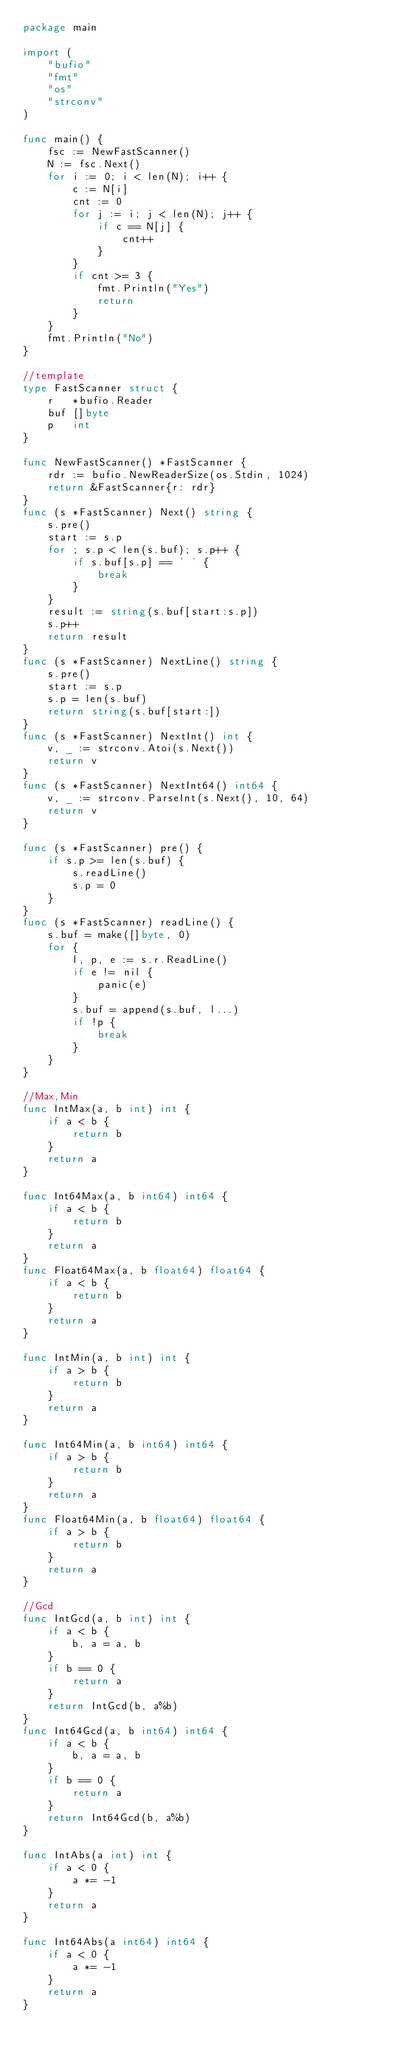Convert code to text. <code><loc_0><loc_0><loc_500><loc_500><_Go_>package main

import (
	"bufio"
	"fmt"
	"os"
	"strconv"
)

func main() {
	fsc := NewFastScanner()
	N := fsc.Next()
	for i := 0; i < len(N); i++ {
		c := N[i]
		cnt := 0
		for j := i; j < len(N); j++ {
			if c == N[j] {
				cnt++
			}
		}
		if cnt >= 3 {
			fmt.Println("Yes")
			return
		}
	}
	fmt.Println("No")
}

//template
type FastScanner struct {
	r   *bufio.Reader
	buf []byte
	p   int
}

func NewFastScanner() *FastScanner {
	rdr := bufio.NewReaderSize(os.Stdin, 1024)
	return &FastScanner{r: rdr}
}
func (s *FastScanner) Next() string {
	s.pre()
	start := s.p
	for ; s.p < len(s.buf); s.p++ {
		if s.buf[s.p] == ' ' {
			break
		}
	}
	result := string(s.buf[start:s.p])
	s.p++
	return result
}
func (s *FastScanner) NextLine() string {
	s.pre()
	start := s.p
	s.p = len(s.buf)
	return string(s.buf[start:])
}
func (s *FastScanner) NextInt() int {
	v, _ := strconv.Atoi(s.Next())
	return v
}
func (s *FastScanner) NextInt64() int64 {
	v, _ := strconv.ParseInt(s.Next(), 10, 64)
	return v
}

func (s *FastScanner) pre() {
	if s.p >= len(s.buf) {
		s.readLine()
		s.p = 0
	}
}
func (s *FastScanner) readLine() {
	s.buf = make([]byte, 0)
	for {
		l, p, e := s.r.ReadLine()
		if e != nil {
			panic(e)
		}
		s.buf = append(s.buf, l...)
		if !p {
			break
		}
	}
}

//Max,Min
func IntMax(a, b int) int {
	if a < b {
		return b
	}
	return a
}

func Int64Max(a, b int64) int64 {
	if a < b {
		return b
	}
	return a
}
func Float64Max(a, b float64) float64 {
	if a < b {
		return b
	}
	return a
}

func IntMin(a, b int) int {
	if a > b {
		return b
	}
	return a
}

func Int64Min(a, b int64) int64 {
	if a > b {
		return b
	}
	return a
}
func Float64Min(a, b float64) float64 {
	if a > b {
		return b
	}
	return a
}

//Gcd
func IntGcd(a, b int) int {
	if a < b {
		b, a = a, b
	}
	if b == 0 {
		return a
	}
	return IntGcd(b, a%b)
}
func Int64Gcd(a, b int64) int64 {
	if a < b {
		b, a = a, b
	}
	if b == 0 {
		return a
	}
	return Int64Gcd(b, a%b)
}

func IntAbs(a int) int {
	if a < 0 {
		a *= -1
	}
	return a
}

func Int64Abs(a int64) int64 {
	if a < 0 {
		a *= -1
	}
	return a
}
</code> 